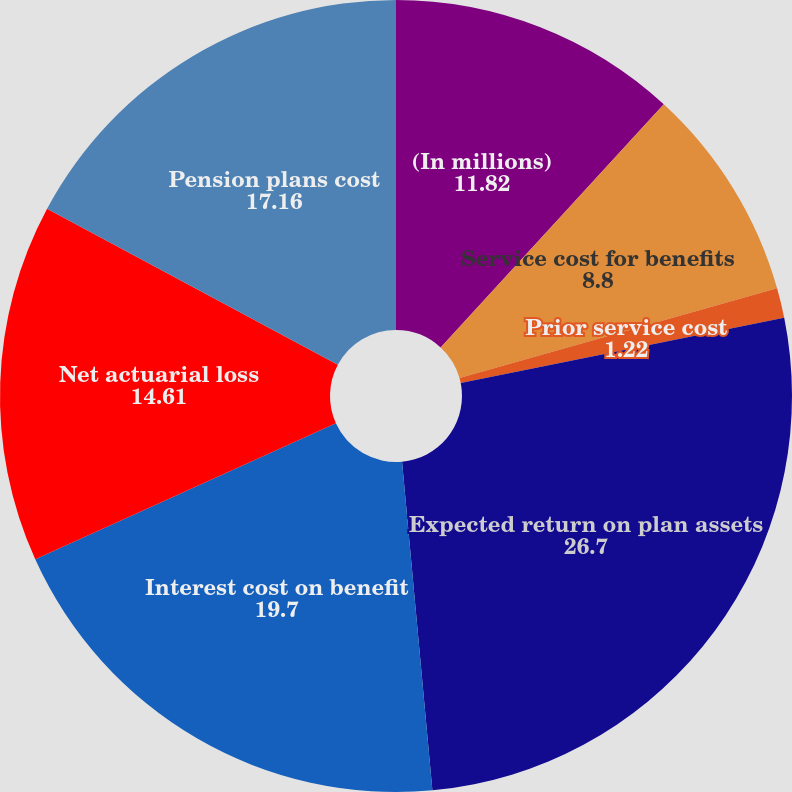<chart> <loc_0><loc_0><loc_500><loc_500><pie_chart><fcel>(In millions)<fcel>Service cost for benefits<fcel>Prior service cost<fcel>Expected return on plan assets<fcel>Interest cost on benefit<fcel>Net actuarial loss<fcel>Pension plans cost<nl><fcel>11.82%<fcel>8.8%<fcel>1.22%<fcel>26.7%<fcel>19.7%<fcel>14.61%<fcel>17.16%<nl></chart> 